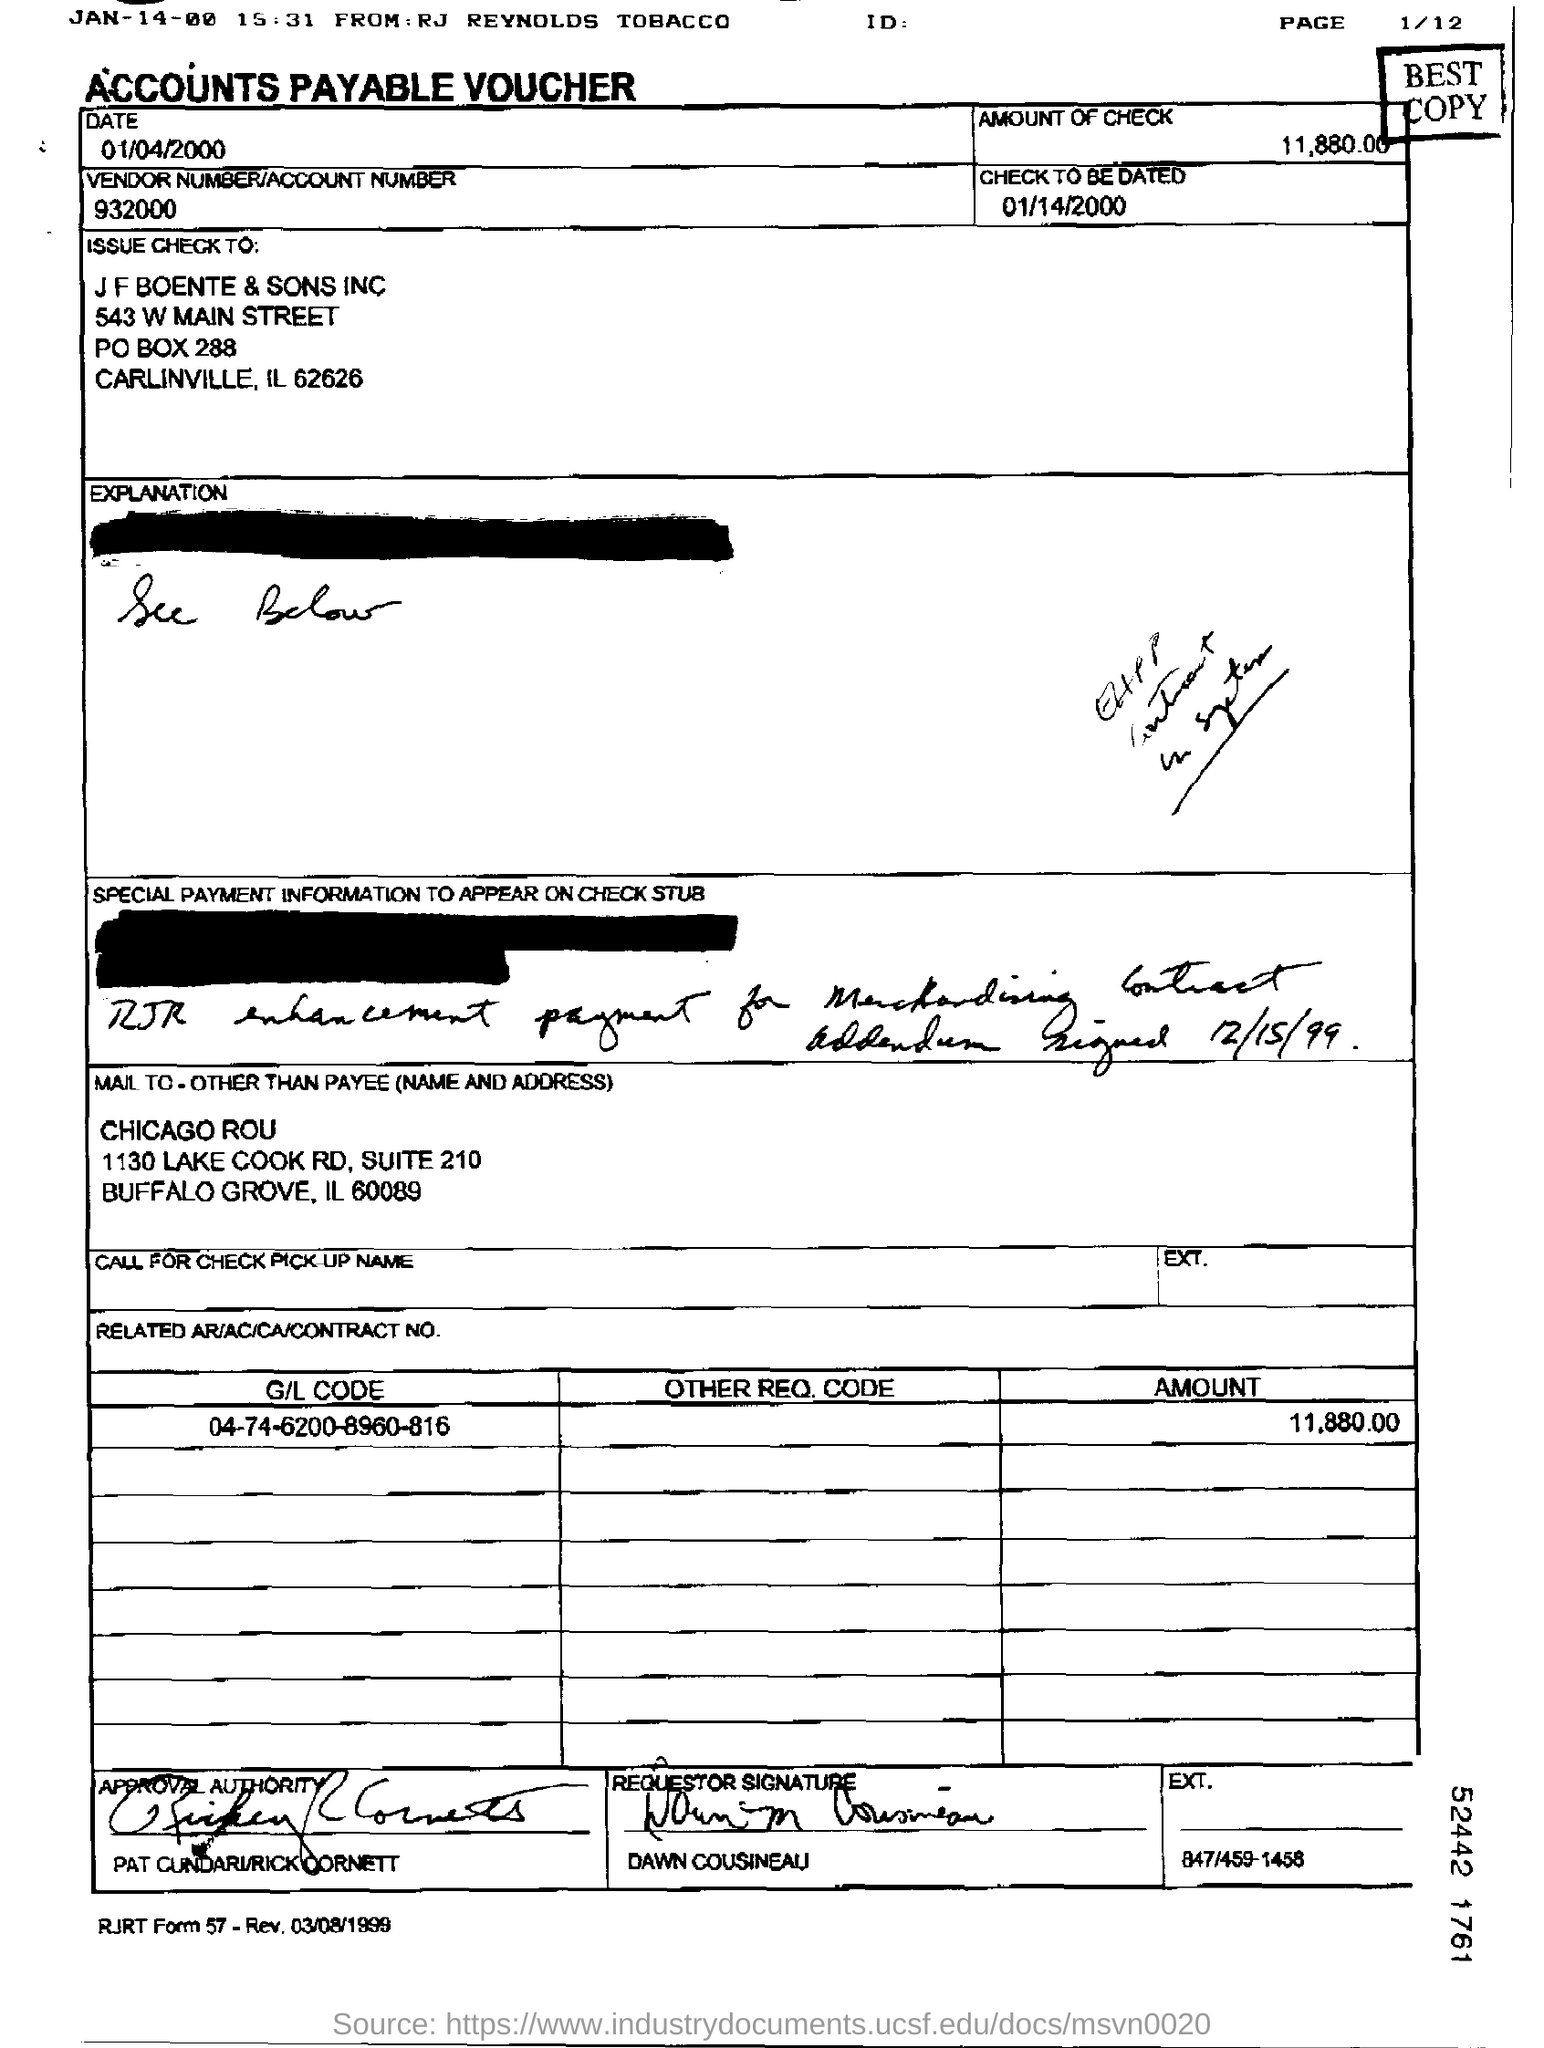What type of voucher is this ?
Your answer should be very brief. ACCOUNTS PAYABLE VOUCHER. What is the check to be dated?
Make the answer very short. 01/14/2000. What is the amount of Check?
Your answer should be very brief. 11,880.00. What is the Vendor Number/Account Number given in the voucher?
Ensure brevity in your answer.  932000. What is the G/L Code mentioned in the voucher?
Make the answer very short. 04-74-6200-8960-816. 